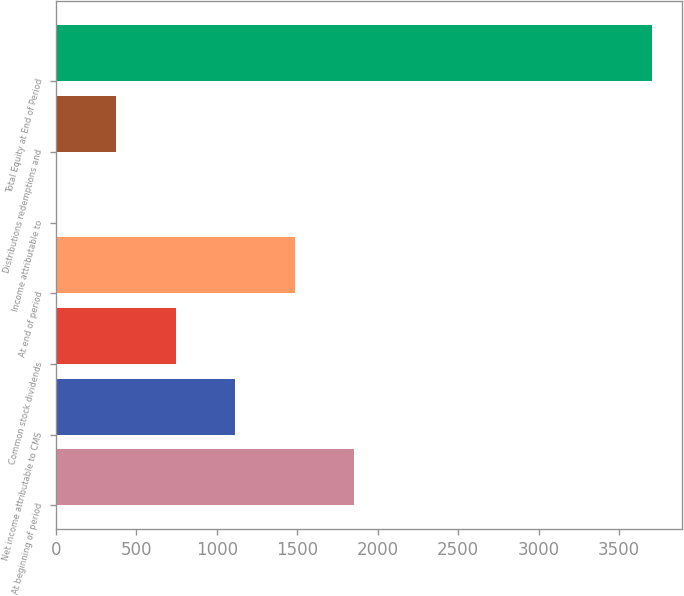<chart> <loc_0><loc_0><loc_500><loc_500><bar_chart><fcel>At beginning of period<fcel>Net income attributable to CMS<fcel>Common stock dividends<fcel>At end of period<fcel>Income attributable to<fcel>Distributions redemptions and<fcel>Total Equity at End of Period<nl><fcel>1854.5<fcel>1113.5<fcel>743<fcel>1484<fcel>2<fcel>372.5<fcel>3707<nl></chart> 